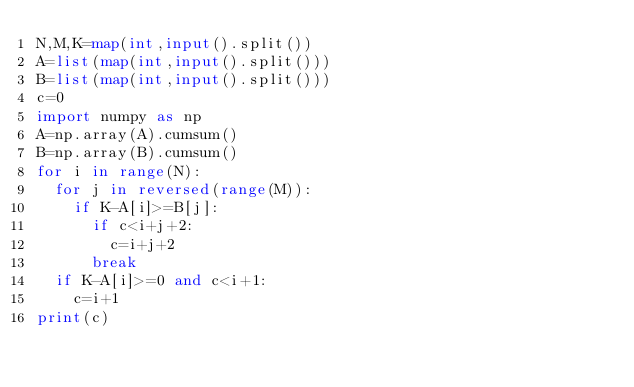<code> <loc_0><loc_0><loc_500><loc_500><_Python_>N,M,K=map(int,input().split())
A=list(map(int,input().split()))
B=list(map(int,input().split()))
c=0
import numpy as np
A=np.array(A).cumsum()
B=np.array(B).cumsum()
for i in range(N):
  for j in reversed(range(M)):
    if K-A[i]>=B[j]:
      if c<i+j+2:
        c=i+j+2
      break
  if K-A[i]>=0 and c<i+1:
    c=i+1
print(c)</code> 